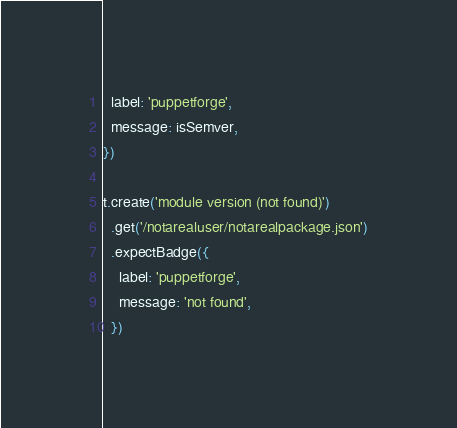Convert code to text. <code><loc_0><loc_0><loc_500><loc_500><_JavaScript_>  label: 'puppetforge',
  message: isSemver,
})

t.create('module version (not found)')
  .get('/notarealuser/notarealpackage.json')
  .expectBadge({
    label: 'puppetforge',
    message: 'not found',
  })
</code> 